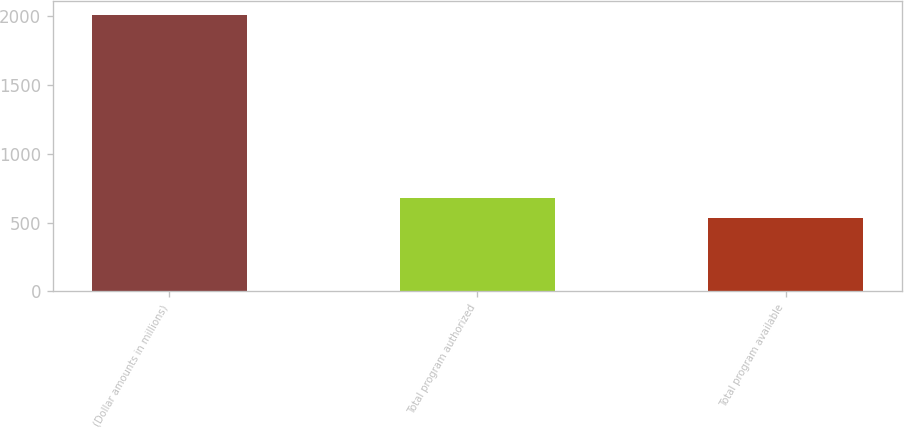<chart> <loc_0><loc_0><loc_500><loc_500><bar_chart><fcel>(Dollar amounts in millions)<fcel>Total program authorized<fcel>Total program available<nl><fcel>2011<fcel>678.1<fcel>530<nl></chart> 